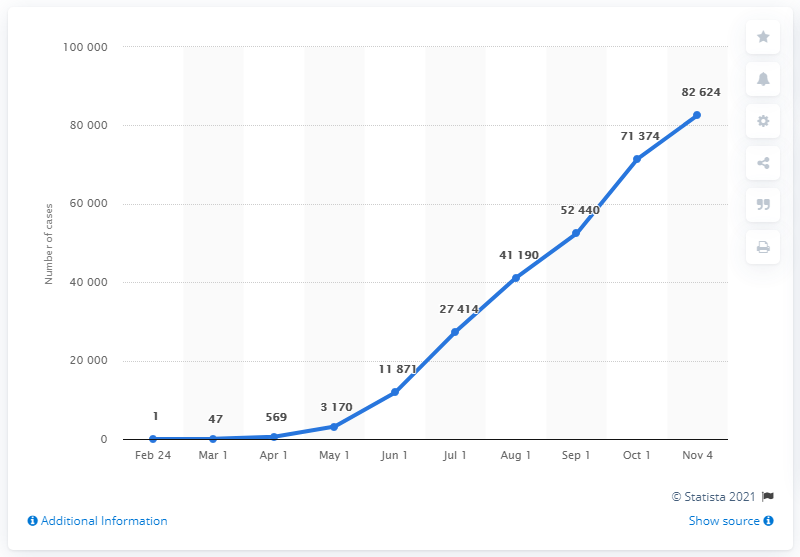Outline some significant characteristics in this image. As of November 4, 2020, there were 8,262 confirmed cases of coronavirus in Bahrain, according to official reports. 